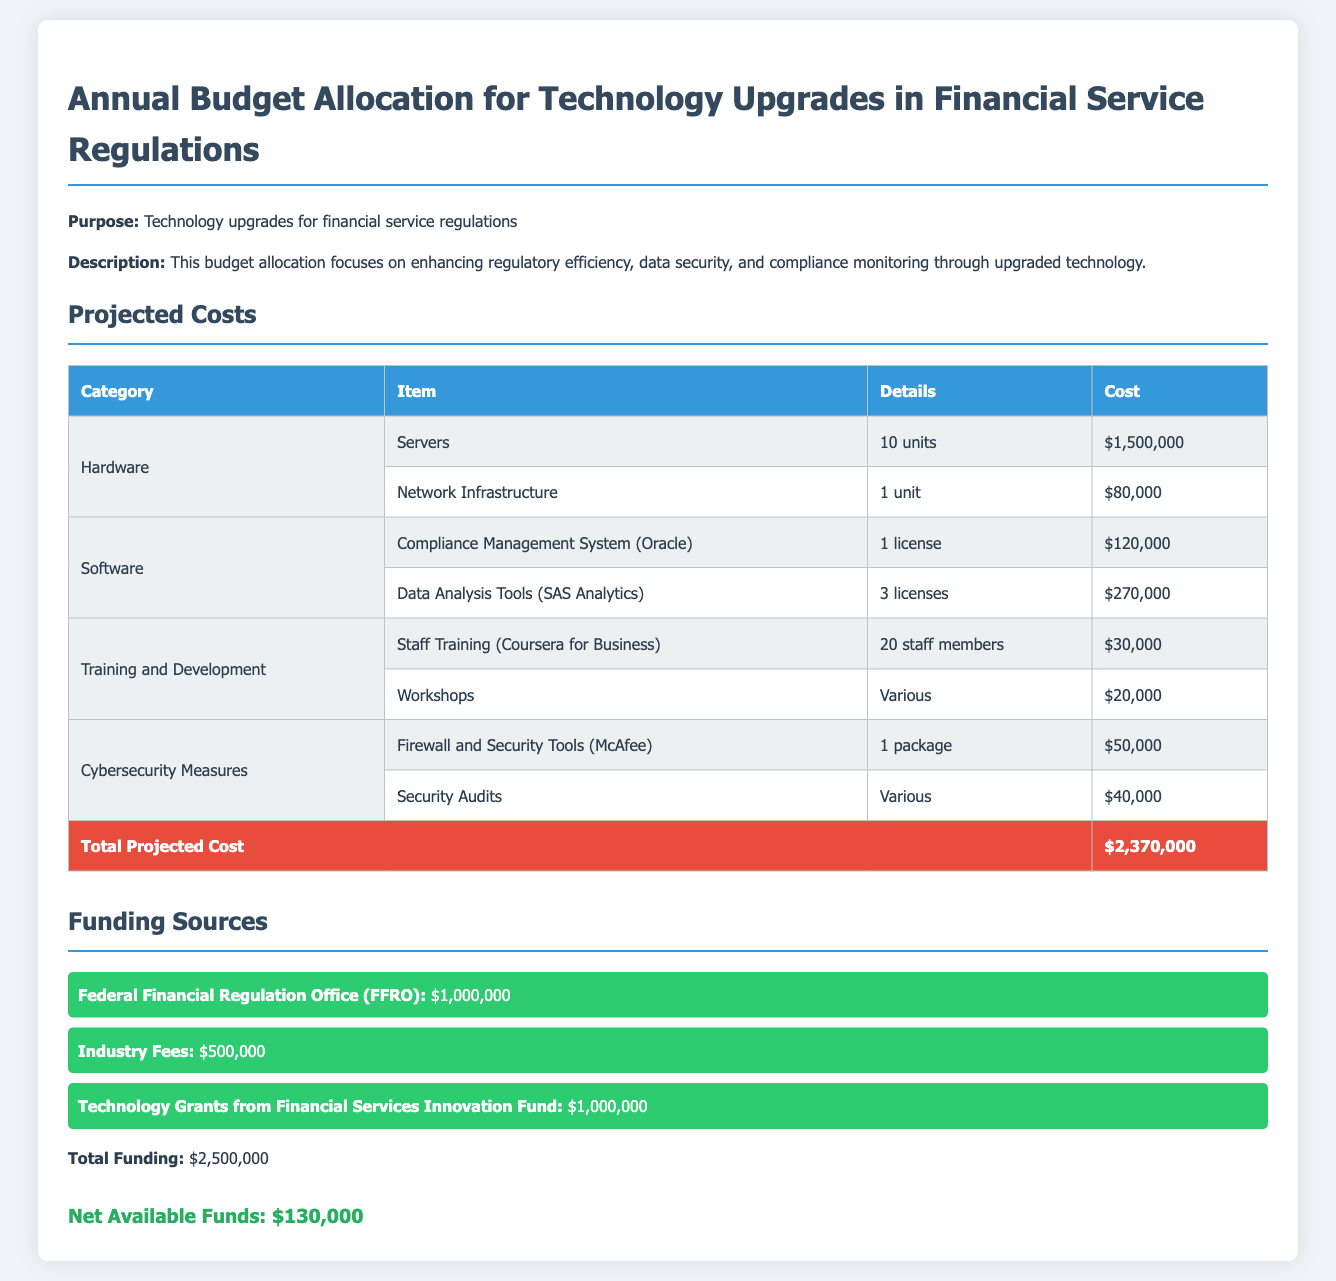What is the total projected cost? The total projected cost is clearly stated in the document's budget section.
Answer: $2,370,000 What is the cost of servers? The document specifies the cost of servers under the hardware category.
Answer: $1,500,000 How much is allocated for cybersecurity measures? The budget section outlines the costs associated with cybersecurity measures.
Answer: $90,000 What is the funding amount from the Federal Financial Regulation Office? The funding sources section lists the contributions from various funding sources, including FFRO.
Answer: $1,000,000 How many licenses are allocated for Data Analysis Tools? The budget details the number of licenses for Data Analysis Tools under the software category.
Answer: 3 licenses What is the net available funds? The document calculates the net available funds after considering the total projected costs and funding sources.
Answer: $130,000 Which organization provides technology grants? The funding sources section mentions an organization that provides technology grants.
Answer: Financial Services Innovation Fund How many staff members are included in training allocation? The document indicates the number of staff members allocated for training under the training and development section.
Answer: 20 staff members What is the total funding? The funding sources section summarizes the total funding amount available for the budget.
Answer: $2,500,000 